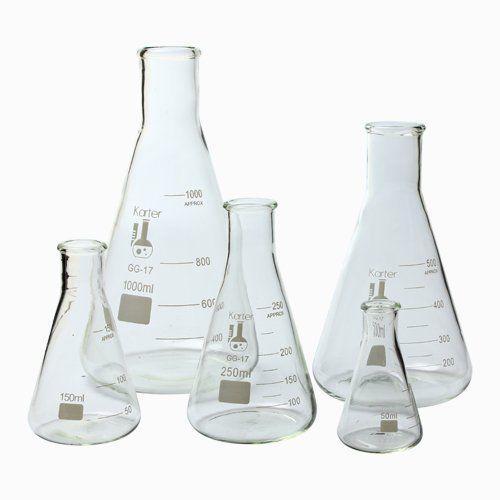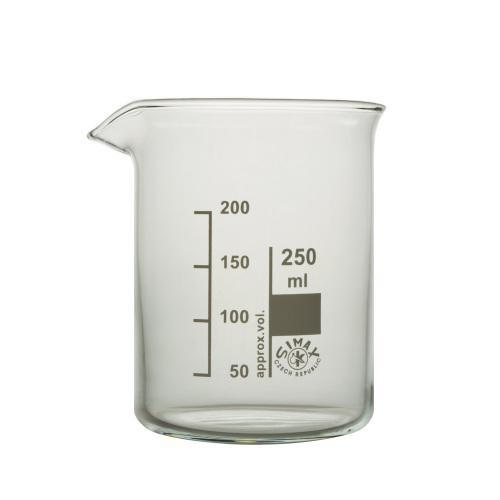The first image is the image on the left, the second image is the image on the right. For the images displayed, is the sentence "There is only one beaker in one of the images, and it has some liquid inside it." factually correct? Answer yes or no. No. The first image is the image on the left, the second image is the image on the right. Evaluate the accuracy of this statement regarding the images: "One of the liquids is green.". Is it true? Answer yes or no. No. 